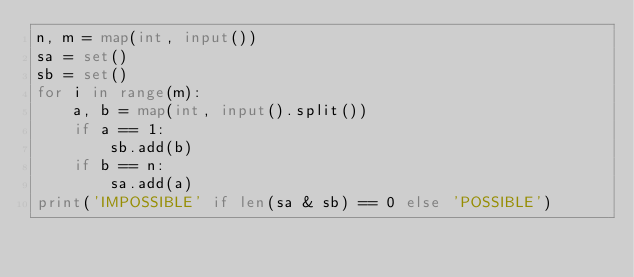Convert code to text. <code><loc_0><loc_0><loc_500><loc_500><_Python_>n, m = map(int, input())
sa = set()
sb = set()
for i in range(m):
    a, b = map(int, input().split())
    if a == 1:
        sb.add(b)
    if b == n:
        sa.add(a)
print('IMPOSSIBLE' if len(sa & sb) == 0 else 'POSSIBLE')</code> 